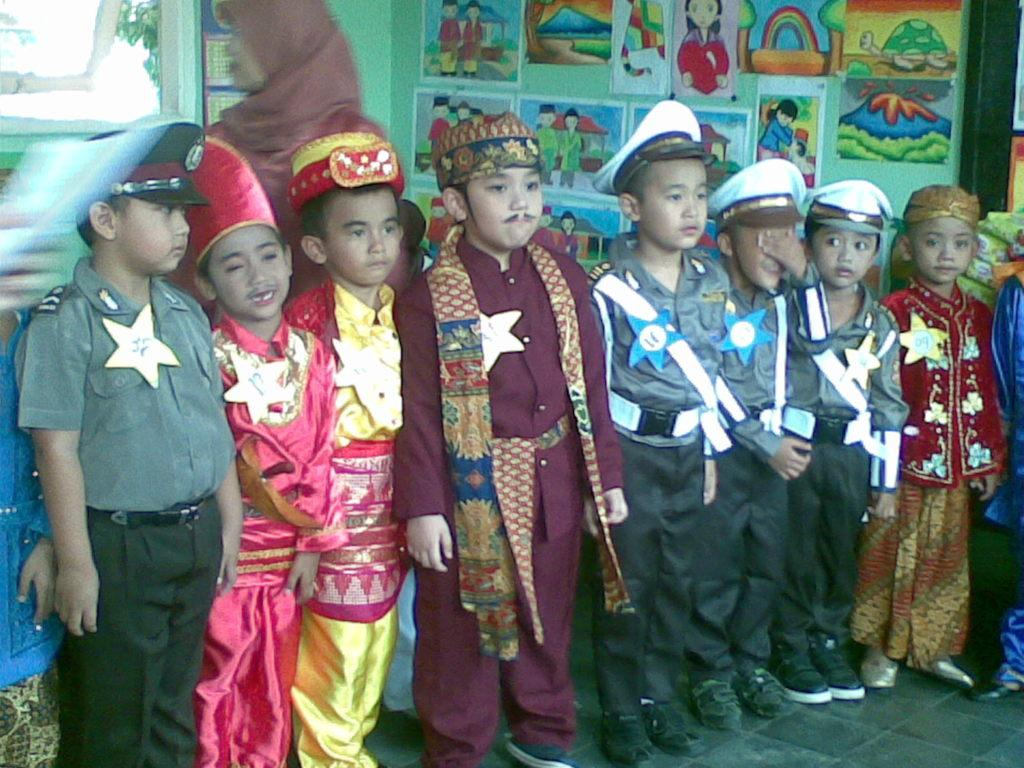Who is present in the image? There are children in the image. What are the children wearing? The children are wearing different costumes, shoes, and caps. What can be seen on the floor in the image? There is a floor visible in the image. What is on the wall in the image? There are posters and drawings on the wall. What type of screw can be seen holding the chair together in the image? There is no chair or screw present in the image; it features children wearing costumes and accessories. How much honey is visible on the wall in the image? There is no honey present in the image; it features posters and drawings on the wall. 